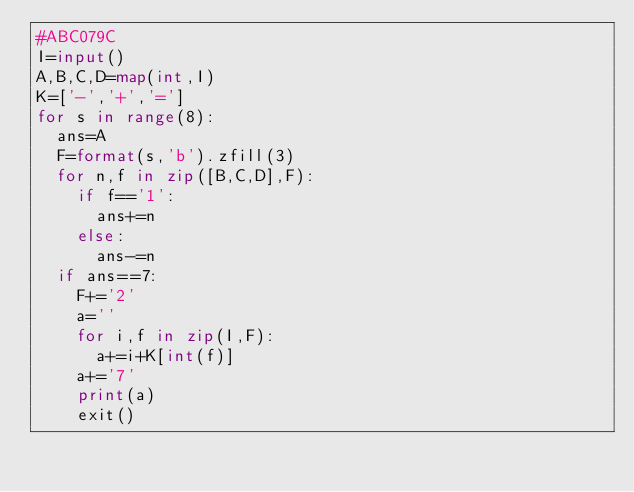Convert code to text. <code><loc_0><loc_0><loc_500><loc_500><_Python_>#ABC079C
I=input()
A,B,C,D=map(int,I)
K=['-','+','=']
for s in range(8):
	ans=A
	F=format(s,'b').zfill(3)
	for n,f in zip([B,C,D],F):
		if f=='1':
			ans+=n
		else:
			ans-=n
	if ans==7:
		F+='2'
		a=''
		for i,f in zip(I,F):
			a+=i+K[int(f)]
		a+='7'
		print(a)
		exit()</code> 